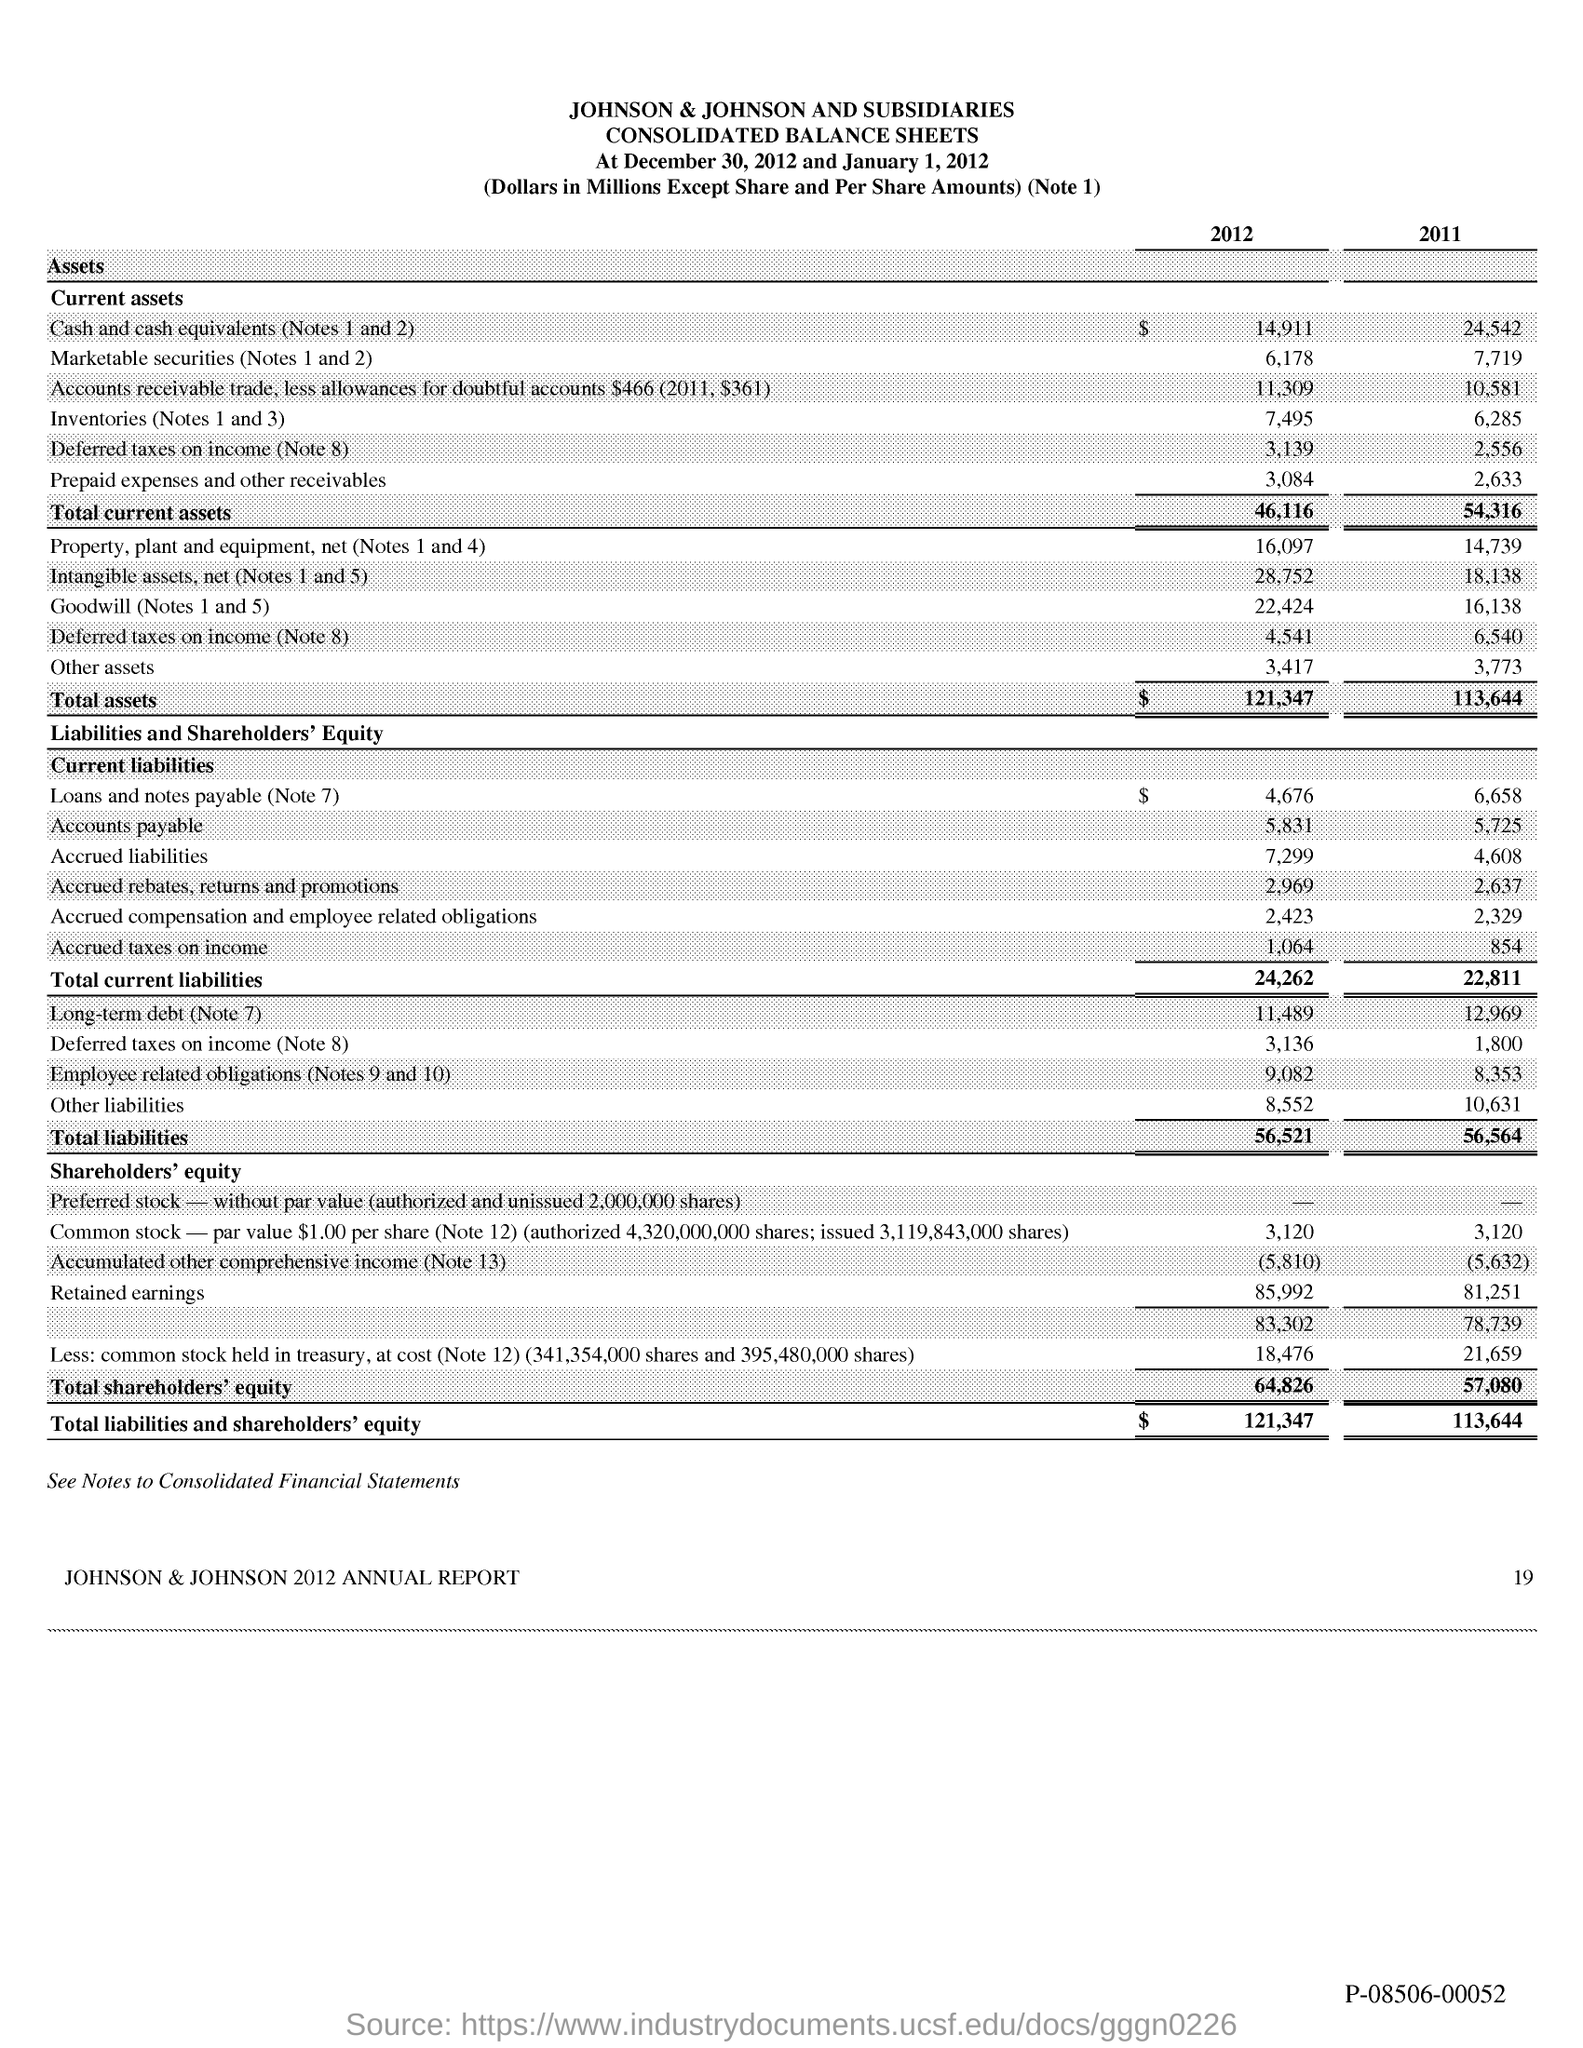Point out several critical features in this image. The total current assets in 2012 were 46,116. In 2011, the total current assets were 54,316. 